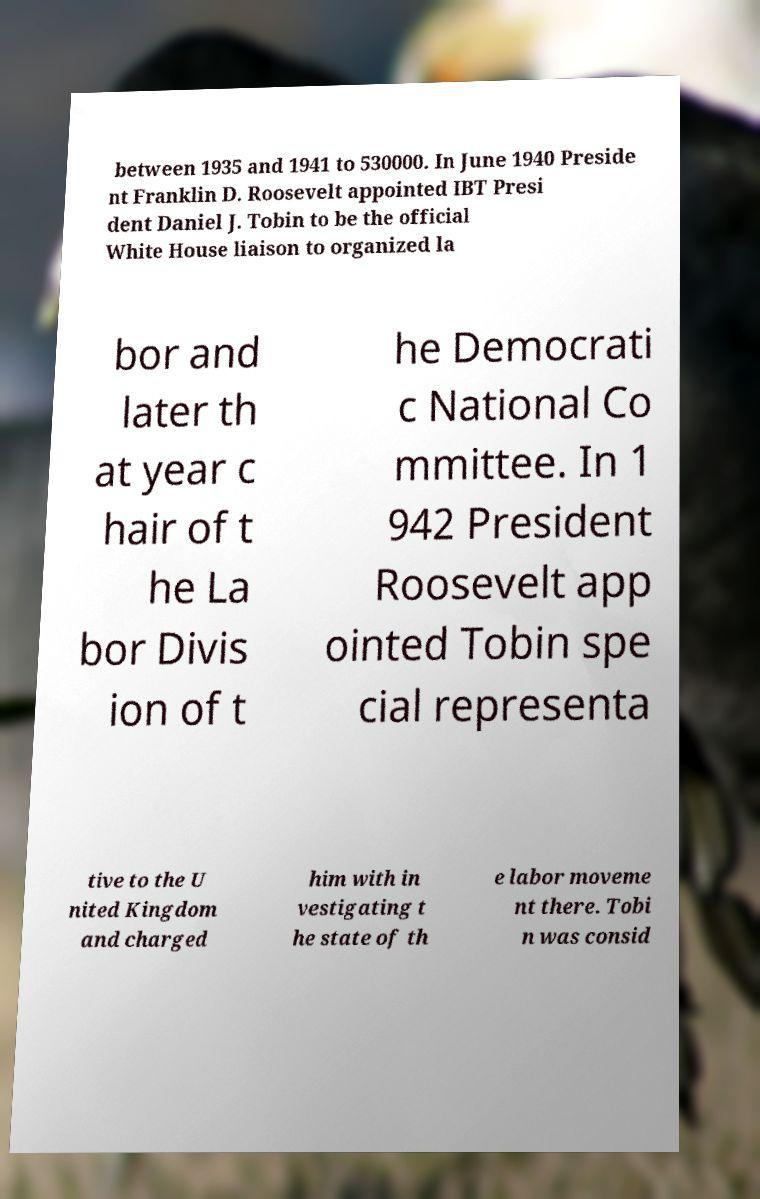Can you accurately transcribe the text from the provided image for me? between 1935 and 1941 to 530000. In June 1940 Preside nt Franklin D. Roosevelt appointed IBT Presi dent Daniel J. Tobin to be the official White House liaison to organized la bor and later th at year c hair of t he La bor Divis ion of t he Democrati c National Co mmittee. In 1 942 President Roosevelt app ointed Tobin spe cial representa tive to the U nited Kingdom and charged him with in vestigating t he state of th e labor moveme nt there. Tobi n was consid 